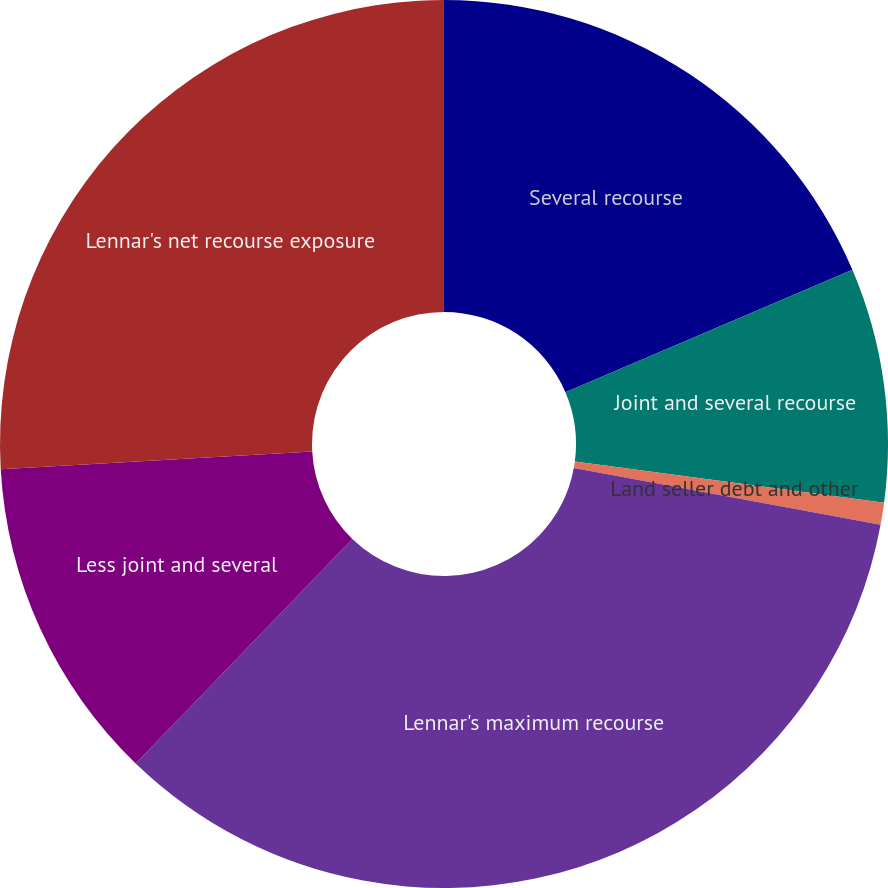Convert chart. <chart><loc_0><loc_0><loc_500><loc_500><pie_chart><fcel>Several recourse<fcel>Joint and several recourse<fcel>Land seller debt and other<fcel>Lennar's maximum recourse<fcel>Less joint and several<fcel>Lennar's net recourse exposure<nl><fcel>18.58%<fcel>8.53%<fcel>0.8%<fcel>34.3%<fcel>11.88%<fcel>25.9%<nl></chart> 